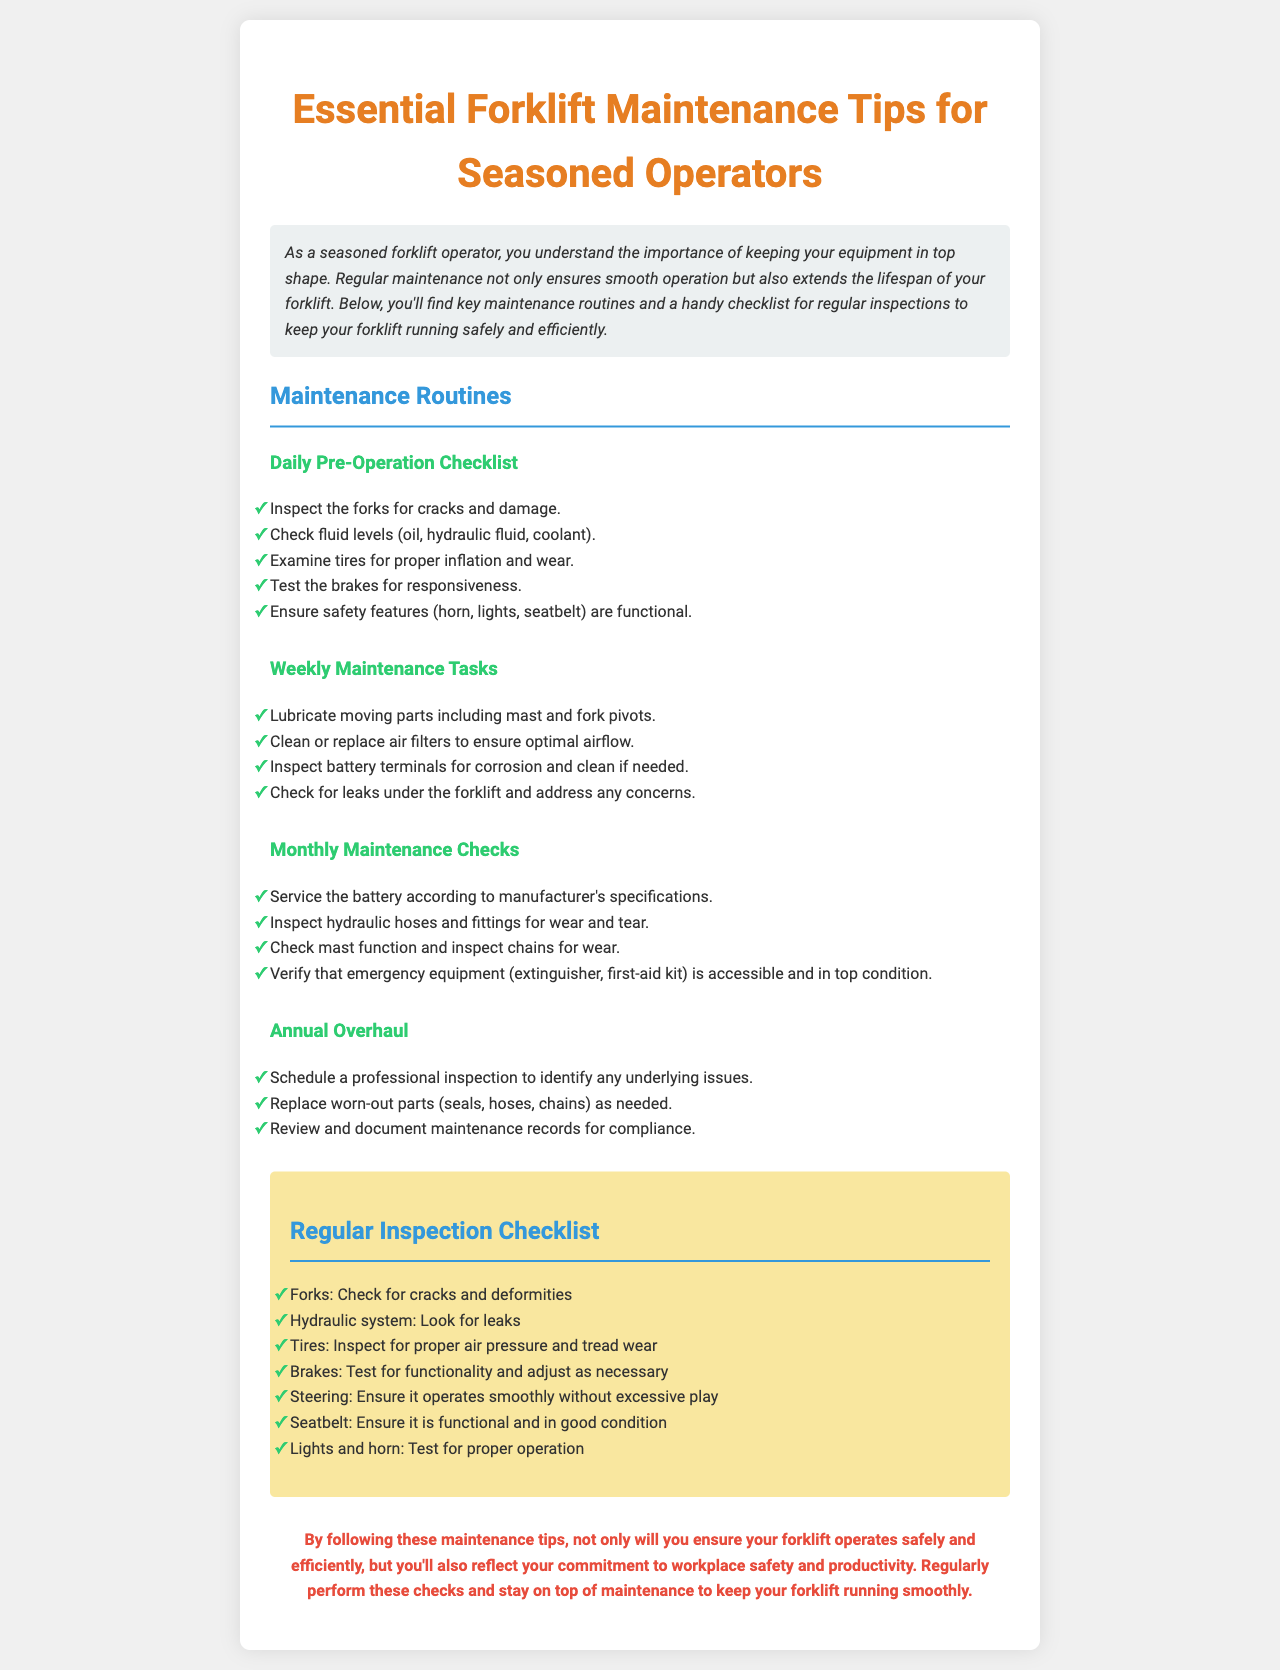What is the title of the newsletter? The title of the newsletter is prominently displayed at the top and is "Essential Forklift Maintenance Tips for Seasoned Operators."
Answer: Essential Forklift Maintenance Tips for Seasoned Operators How many maintenance routines are listed? The document includes four main categories of maintenance routines mentioned in the maintenance section.
Answer: Four What should be checked for in the daily pre-operation checklist? The daily pre-operation checklist includes inspecting the forks, checking fluid levels, examining tires, testing brakes, and ensuring safety features are functional.
Answer: Forks, fluid levels, tires, brakes, safety features What color are the headings for the maintenance routines? The headings for the maintenance routines are styled with a specific color designated for emphasis in the document.
Answer: Green What is included in the regular inspection checklist? The regular inspection checklist includes checking forks, hydraulic system, tires, brakes, steering, seatbelt, and lights and horn.
Answer: Forks, hydraulic system, tires, brakes, steering, seatbelt, lights and horn What is the function of the newsletter's conclusion? The conclusion emphasizes the importance of following maintenance tips to ensure safety and efficiency in forklift operation.
Answer: Importance of following maintenance tips How often should the battery be serviced? The document specifies that the battery should be serviced according to the manufacturer's specifications on a monthly basis.
Answer: Monthly What does the annual overhaul involve? The annual overhaul involves scheduling a professional inspection and replacing worn-out parts as needed.
Answer: Professional inspection and replacing worn-out parts 